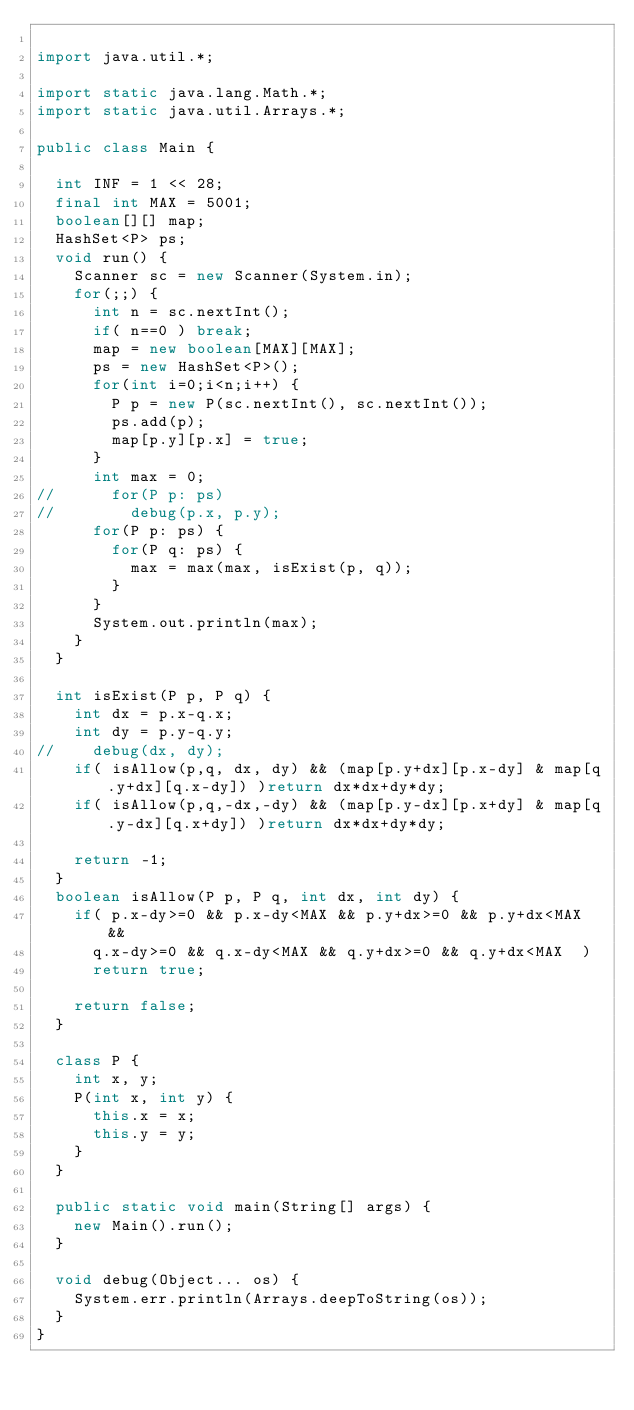Convert code to text. <code><loc_0><loc_0><loc_500><loc_500><_Java_>
import java.util.*;

import static java.lang.Math.*;
import static java.util.Arrays.*;

public class Main {

	int INF = 1 << 28;
	final int MAX = 5001;
	boolean[][] map;
	HashSet<P> ps;
	void run() {
		Scanner sc = new Scanner(System.in);
		for(;;) {
			int n = sc.nextInt();
			if( n==0 ) break;
			map = new boolean[MAX][MAX];
			ps = new HashSet<P>();
			for(int i=0;i<n;i++) {
				P p = new P(sc.nextInt(), sc.nextInt());
				ps.add(p);
				map[p.y][p.x] = true;
			}
			int max = 0;
//			for(P p: ps)
//				debug(p.x, p.y);
			for(P p: ps) {
				for(P q: ps) {
					max = max(max, isExist(p, q));
				}
			}
			System.out.println(max);
		}
	}
	
	int isExist(P p, P q) {
		int dx = p.x-q.x;
		int dy = p.y-q.y;
//		debug(dx, dy);
		if( isAllow(p,q, dx, dy) && (map[p.y+dx][p.x-dy] & map[q.y+dx][q.x-dy]) )return dx*dx+dy*dy;
		if( isAllow(p,q,-dx,-dy) && (map[p.y-dx][p.x+dy] & map[q.y-dx][q.x+dy]) )return dx*dx+dy*dy;
		
		return -1;
	}
	boolean isAllow(P p, P q, int dx, int dy) {
		if( p.x-dy>=0 && p.x-dy<MAX && p.y+dx>=0 && p.y+dx<MAX && 
			q.x-dy>=0 && q.x-dy<MAX && q.y+dx>=0 && q.y+dx<MAX  )
			return true;
		
		return false;
	}
	
	class P {
		int x, y;
		P(int x, int y) {
			this.x = x;
			this.y = y;
		}
	}

	public static void main(String[] args) {
		new Main().run();
	}

	void debug(Object... os) {
		System.err.println(Arrays.deepToString(os));
	}
}</code> 